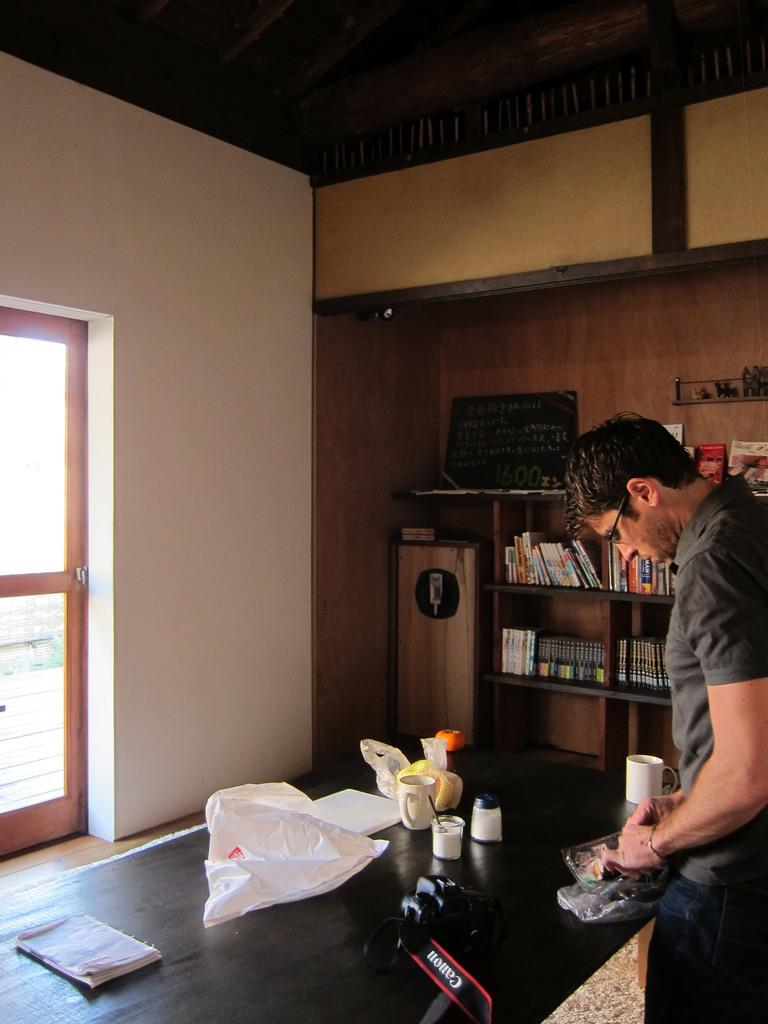Provide a one-sentence caption for the provided image. a man standing at a counter next to a canon camera. 